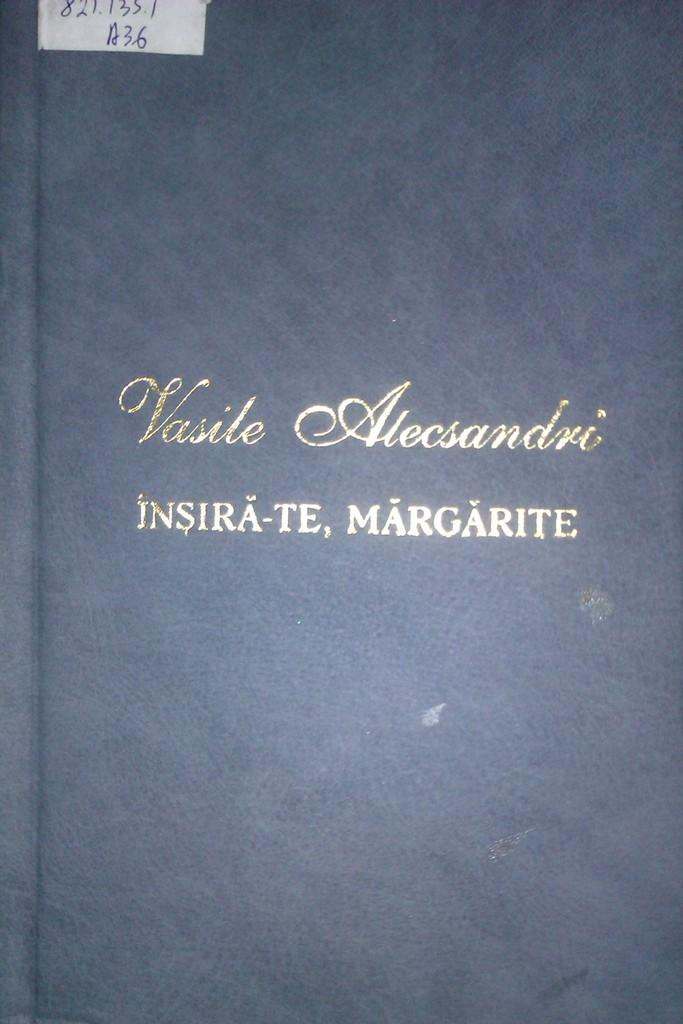<image>
Write a terse but informative summary of the picture. a cover of a book called Vasile Alecsandri has gold letters on a blue background 